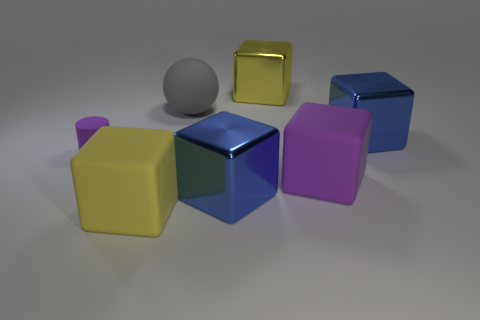Is there any other thing that is the same shape as the small purple rubber object?
Provide a succinct answer. No. Are there any other things that are the same size as the matte cylinder?
Your response must be concise. No. How big is the blue metallic thing in front of the rubber cylinder?
Make the answer very short. Large. The ball that is the same size as the yellow shiny block is what color?
Your answer should be compact. Gray. Does the gray sphere have the same size as the matte cylinder?
Your answer should be very brief. No. How big is the rubber object that is behind the large purple object and right of the purple matte cylinder?
Your response must be concise. Large. How many rubber things are either large gray things or blocks?
Your answer should be very brief. 3. Are there more metallic cubes on the left side of the yellow shiny block than large red blocks?
Your response must be concise. Yes. There is a blue block in front of the purple matte cylinder; what is its material?
Provide a succinct answer. Metal. What number of things have the same material as the small cylinder?
Give a very brief answer. 3. 